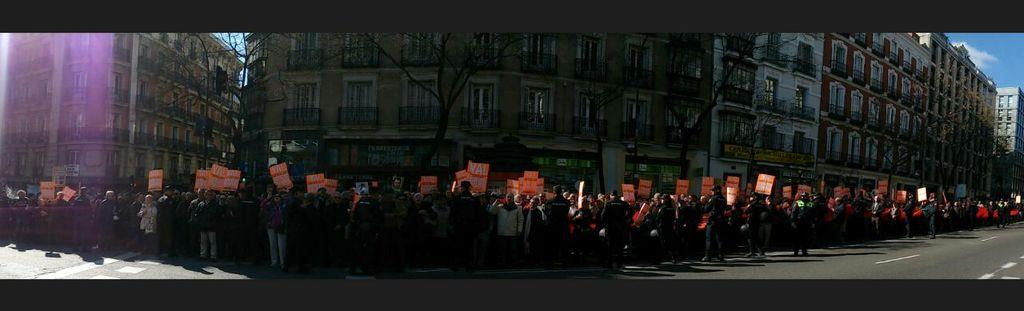How many people are in the image? There is a group of people in the image, but the exact number is not specified. What are the people holding in the image? The people are holding boards with written text in the image. What type of structures can be seen in the image? There are buildings in the image. What architectural feature is visible in the image? There are windows visible in the image. What type of pathway is present in the image? There is a road in the image. What is visible at the top of the image? The sky is visible at the top of the image. Can you tell me how many knots are tied on the lawyer's tie in the image? There is no lawyer or tie present in the image; it features a group of people holding boards with written text, buildings, windows, a road, and the sky. 